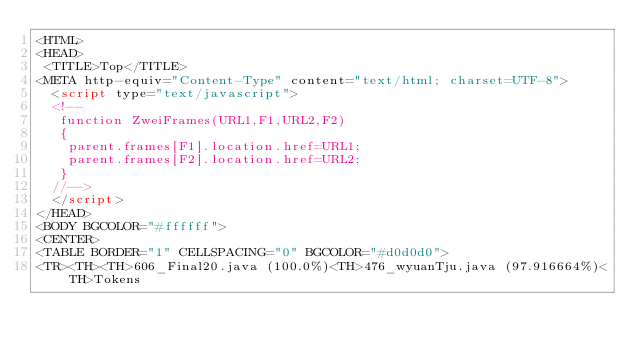Convert code to text. <code><loc_0><loc_0><loc_500><loc_500><_HTML_><HTML>
<HEAD>
 <TITLE>Top</TITLE>
<META http-equiv="Content-Type" content="text/html; charset=UTF-8">
  <script type="text/javascript">
  <!--
   function ZweiFrames(URL1,F1,URL2,F2)
   {
    parent.frames[F1].location.href=URL1;
    parent.frames[F2].location.href=URL2;
   }
  //-->
  </script>
</HEAD>
<BODY BGCOLOR="#ffffff">
<CENTER>
<TABLE BORDER="1" CELLSPACING="0" BGCOLOR="#d0d0d0">
<TR><TH><TH>606_Final20.java (100.0%)<TH>476_wyuanTju.java (97.916664%)<TH>Tokens</code> 